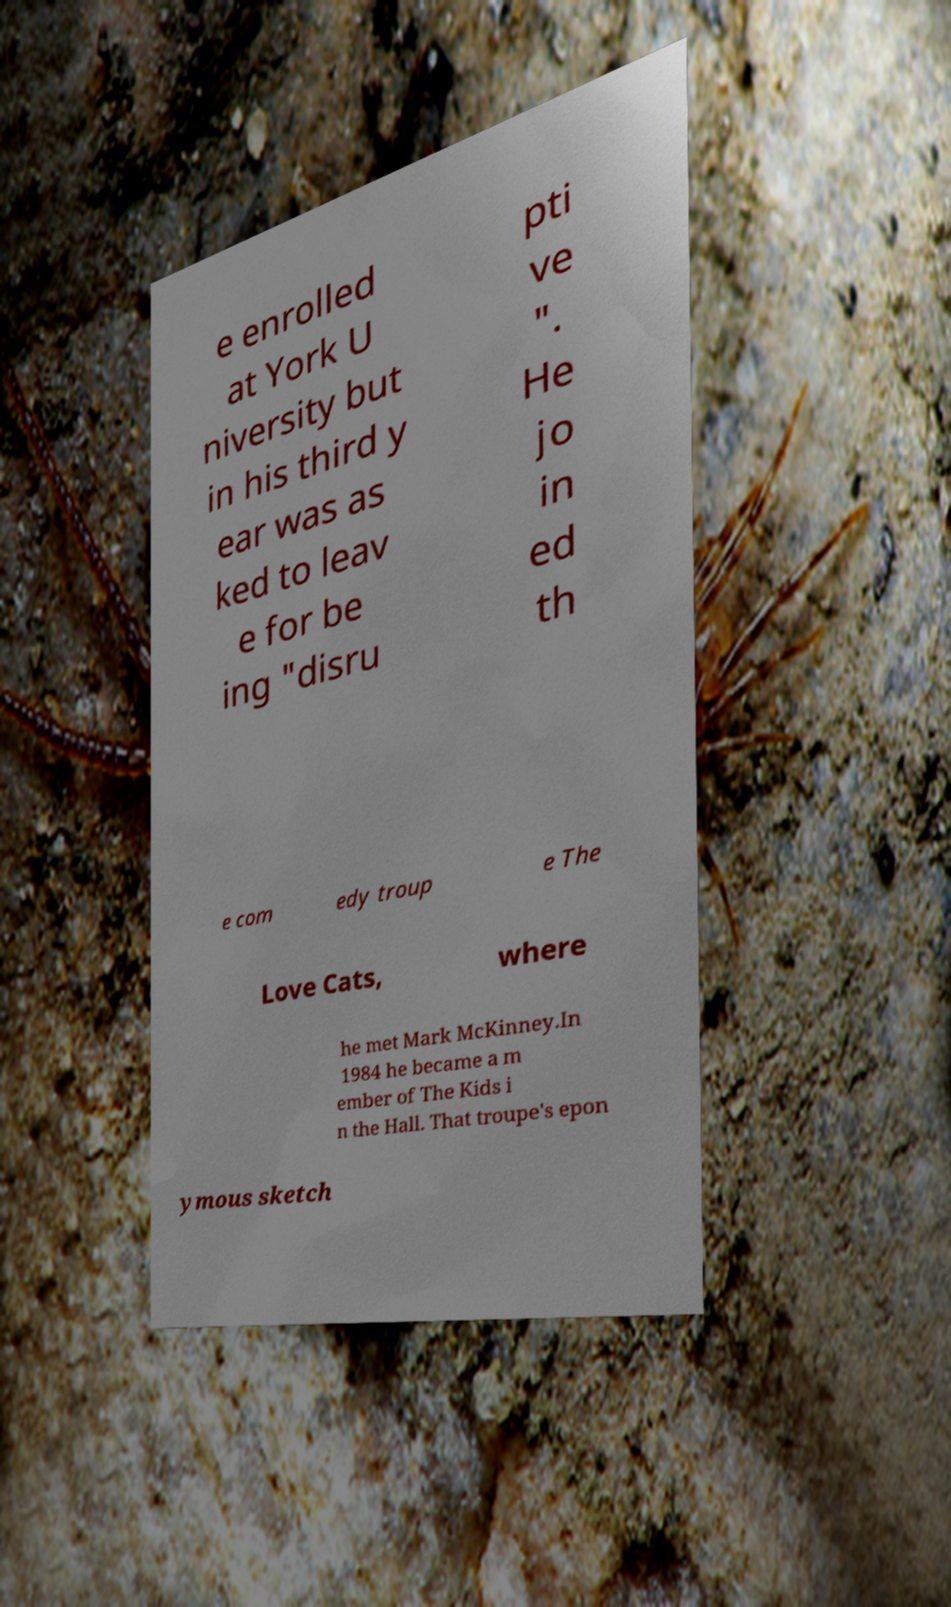For documentation purposes, I need the text within this image transcribed. Could you provide that? e enrolled at York U niversity but in his third y ear was as ked to leav e for be ing "disru pti ve ". He jo in ed th e com edy troup e The Love Cats, where he met Mark McKinney.In 1984 he became a m ember of The Kids i n the Hall. That troupe's epon ymous sketch 